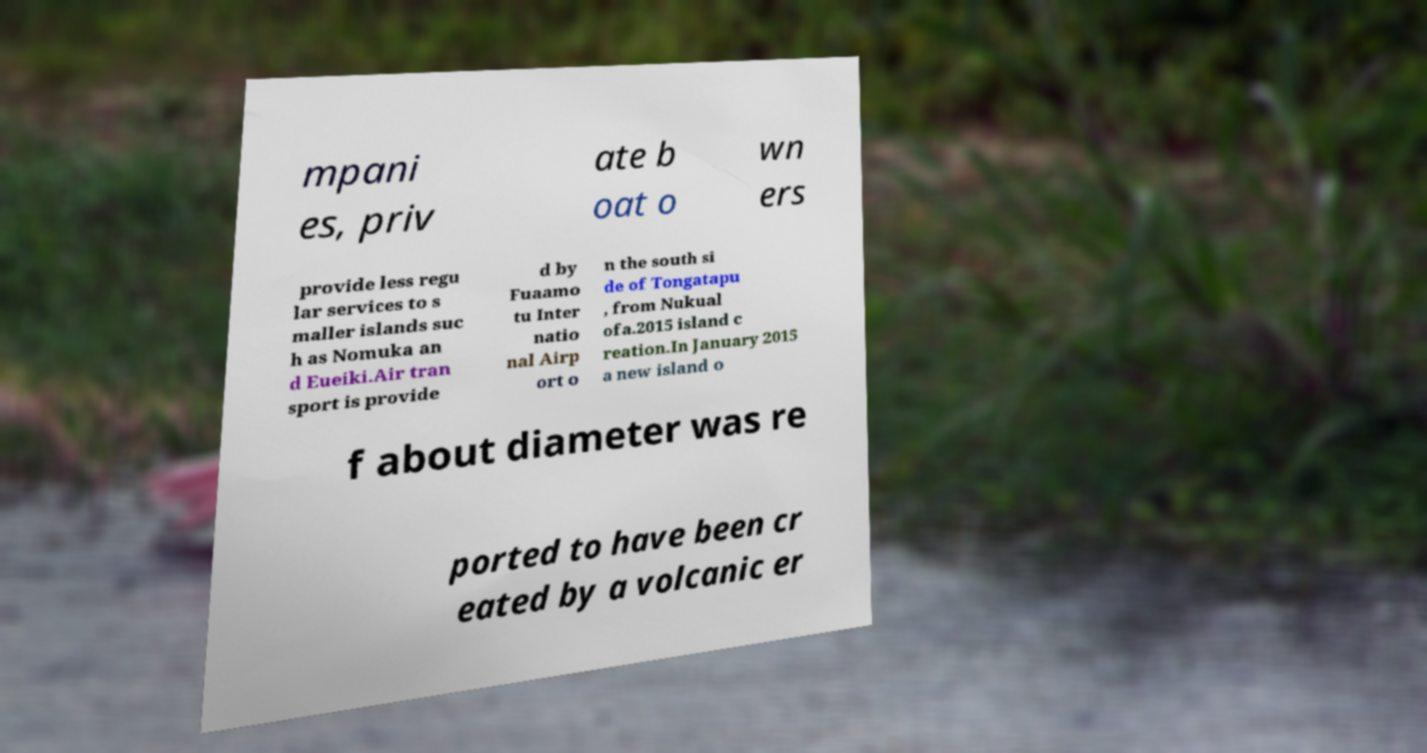What messages or text are displayed in this image? I need them in a readable, typed format. mpani es, priv ate b oat o wn ers provide less regu lar services to s maller islands suc h as Nomuka an d Eueiki.Air tran sport is provide d by Fuaamo tu Inter natio nal Airp ort o n the south si de of Tongatapu , from Nukual ofa.2015 island c reation.In January 2015 a new island o f about diameter was re ported to have been cr eated by a volcanic er 